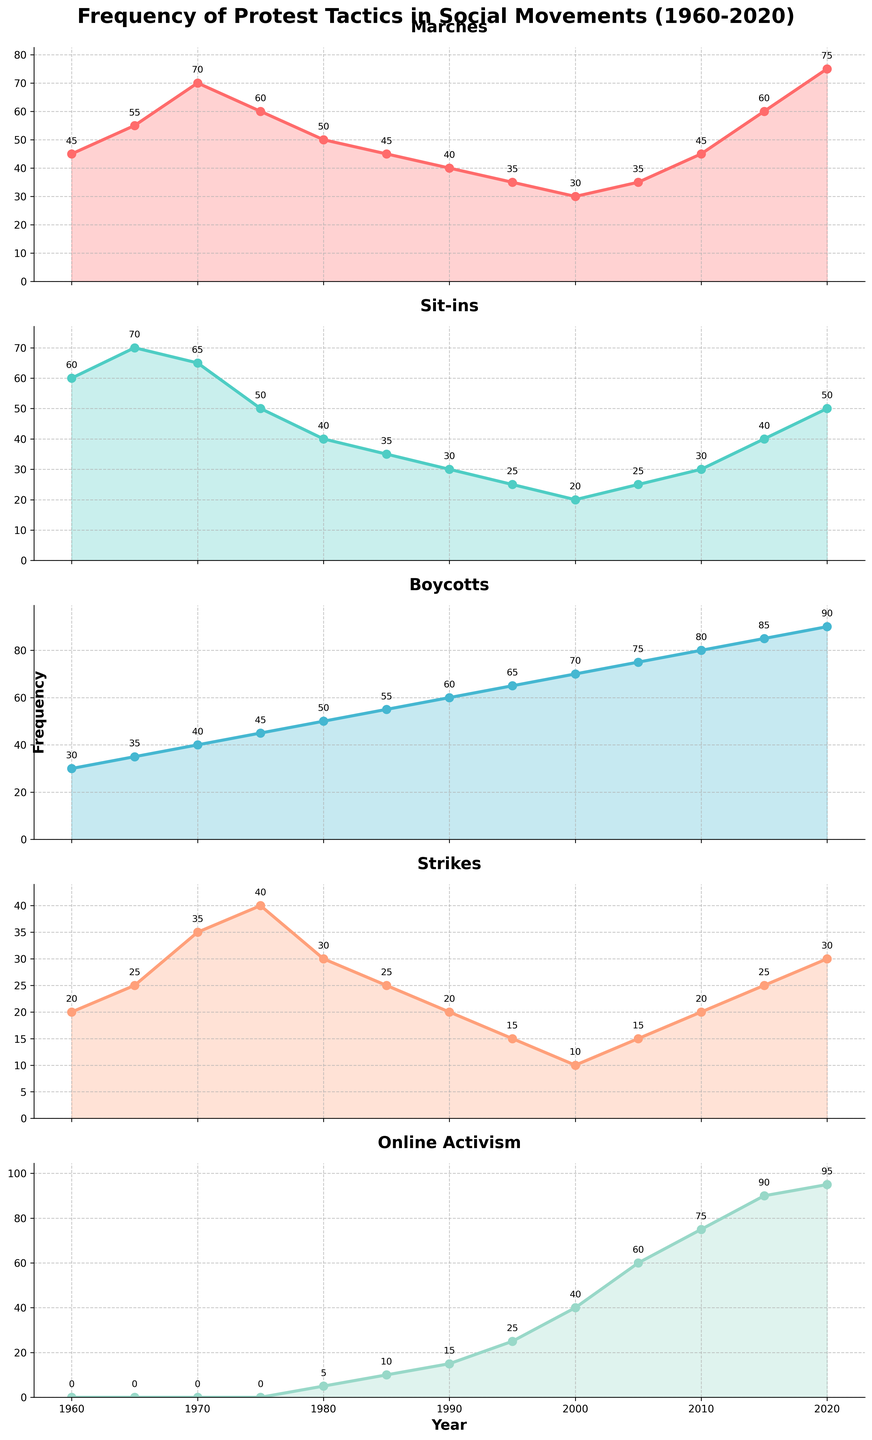How has the frequency of marches changed from 1960 to 2020? By examining the plot for Marches, we start at 45 in 1960 and end at 75 in 2020. It has increased by 30.
Answer: The frequency increased from 45 to 75 Which protest tactic saw the highest frequency in 2020? By reviewing the data in 2020 across all plots, Online Activism has the highest value at 95.
Answer: Online Activism What is the average frequency of sit-ins across the years? Sum the frequencies for Sit-ins from 1960 to 2020 and divide by the number of years (13 points): (60 + 70 + 65 + 50 + 40 + 35 + 30 + 25 + 20 + 25 + 30 + 40 + 50) / 13 = 41.92.
Answer: Approximately 41.92 Compare the frequencies of boycotts in 1960 and 2020. Has it increased or decreased? In 1960, boycotts had a frequency of 30. In 2020, it was 90. The frequency has increased.
Answer: It increased Which years saw a decline in the number of strikes compared to the previous recorded data point? By comparing each year to its previous data point in the Strikes plot, declines occurred from 1975 to 1980 (40 to 30), 1980 to 1985 (30 to 25), 1985 to 1990 (25 to 20), 1990 to 1995 (20 to 15), and 2010 to 2015 (20 to 25).
Answer: 1980, 1985, 1990, 1995, 2015 In what year did marches peak, and what was the frequency? Examine the Marches plot to find the year with the highest peak, which is 2020 with a frequency of 75.
Answer: 2020 with a frequency of 75 Was there any year where more than one protest tactic reached the same frequency? By scanning through each year's data, there is no evidence of multiple tactics having the same frequency at any given year in the supplied data.
Answer: No What are the differences in frequency between Strikes and Boycotts in 1970? In 1970, the frequency for Boycotts was 40 and for Strikes was 35. The difference is 40 - 35 = 5.
Answer: 5 Identify the year when Online Activism started increasing notably. By examining the Online Activism plot, noticeable increases start from 1980 onwards with a significant rise observed from 2000 to 2020.
Answer: 2000 onward Calculate the percentage increase in the frequency of Boycotts from 2000 to 2020. In 2000, Boycotts have a frequency of 70. In 2020, it is 90. The percentage increase is calculated as [(90 - 70) / 70] * 100 = 28.57%.
Answer: 28.57% 